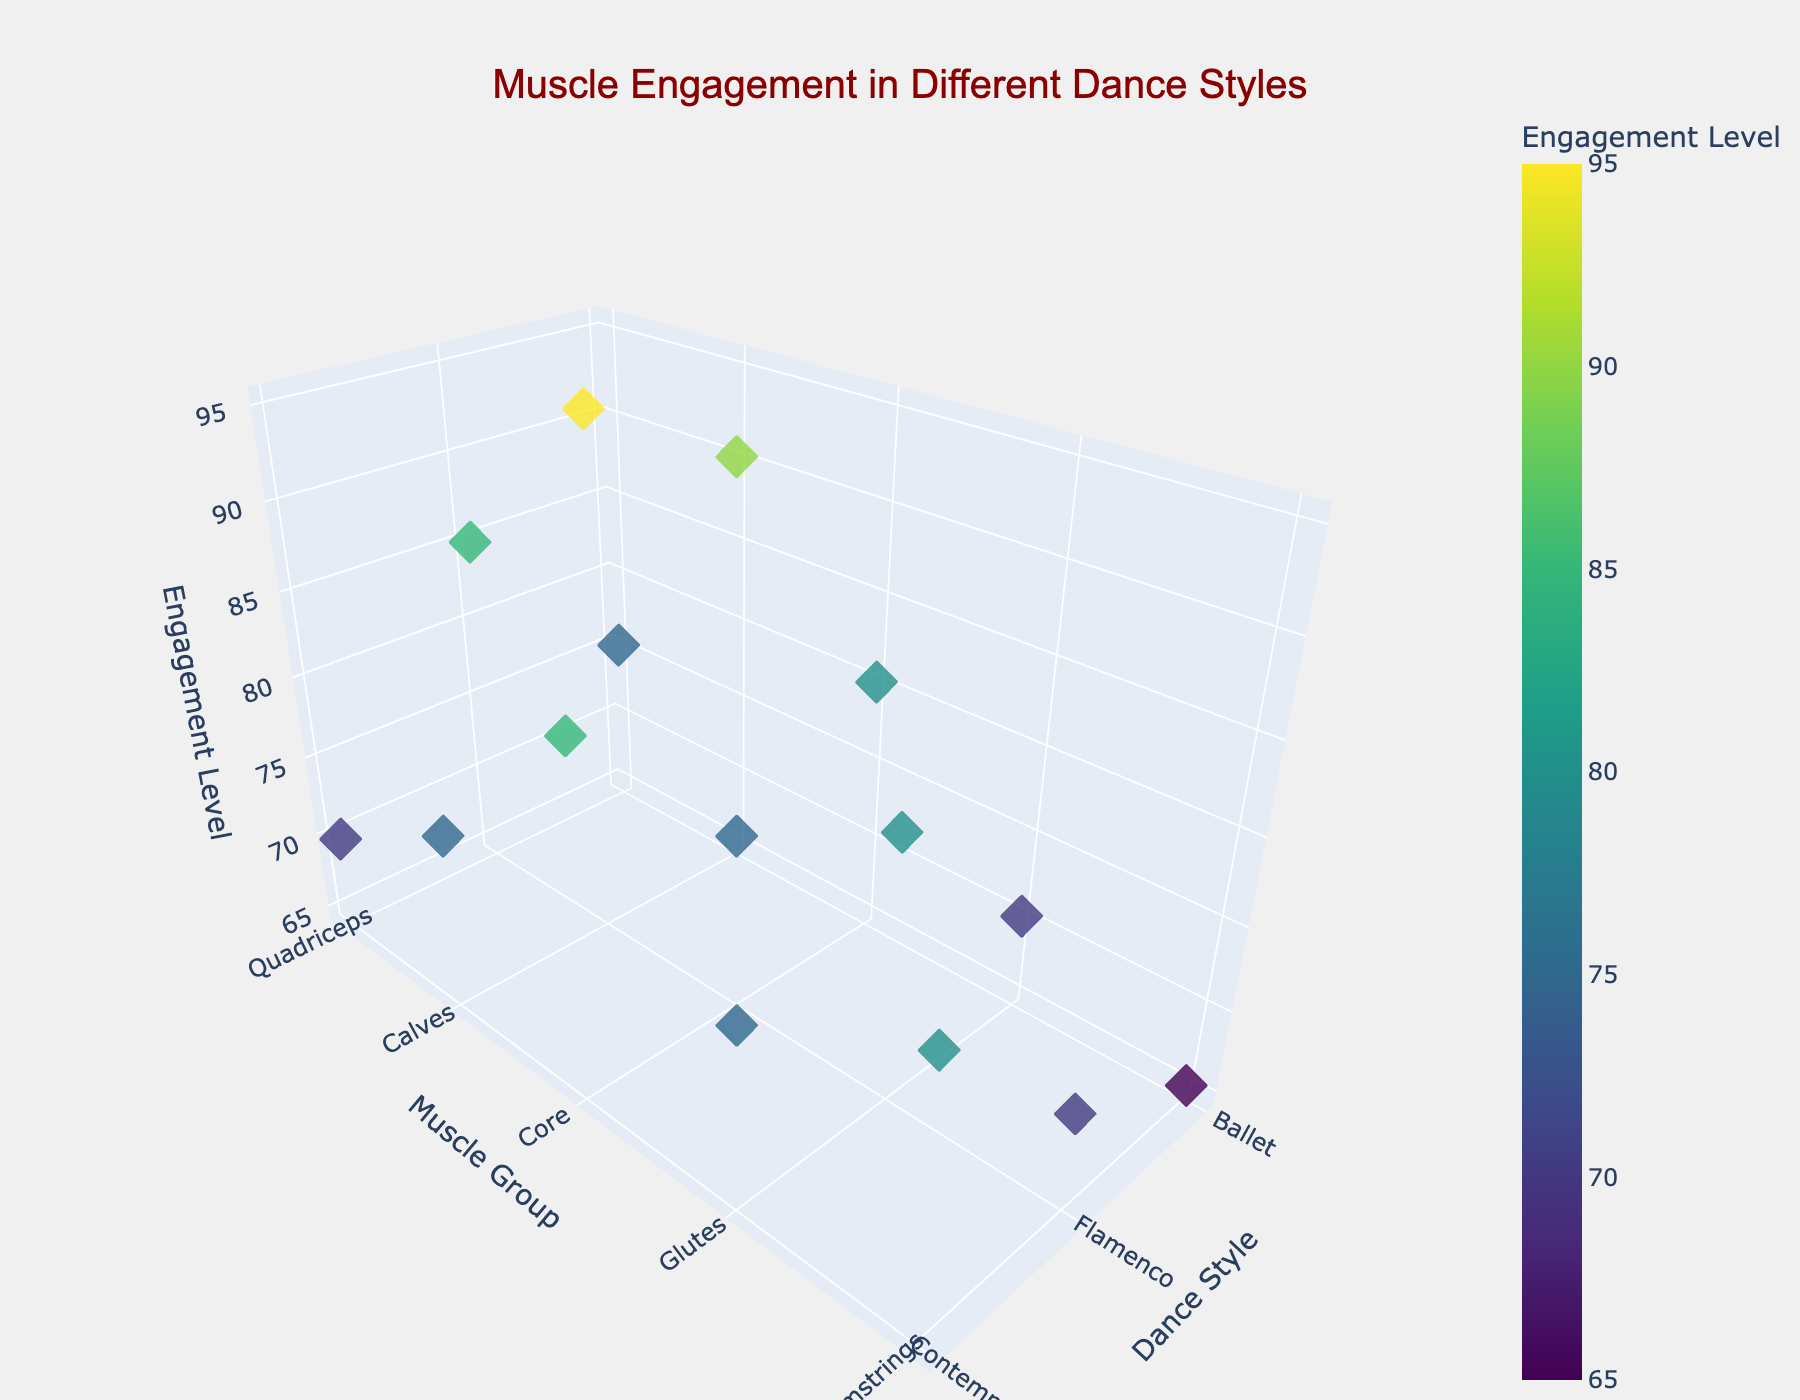What's the title of the plot? The title is typically located at the top of the plot, and it provides a summary of what the plot is about. In this case, the title states "Muscle Engagement in Different Dance Styles."
Answer: Muscle Engagement in Different Dance Styles What does the color scale represent? The color scale, often found as a color bar on the side of the plot, indicates that colors represent different levels of muscle engagement. Darker colors indicate higher engagement levels.
Answer: Engagement Level Which muscle group has the highest engagement level in flamenco? By looking at the y-axis for 'Flamenco' and finding the highest point on the z-axis, you can identify that 'Calves' have the highest engagement level of 95.
Answer: Calves Compare the core muscle engagement between ballet and contemporary dance. Which one is higher? By locating both 'Ballet' and 'Contemporary' groups on the y-axis for the 'Core' muscle, we see that Ballet has an engagement level of 80, and Contemporary has an engagement level of 85. Therefore, Contemporary has a higher core muscle engagement.
Answer: Contemporary What's the average engagement level for the glutes across all dance styles? First, identify the engagement levels for the glutes in ballet, flamenco, and contemporary, which are 70, 80, and 75, respectively. Sum these values (70+80+75 = 225) and divide by the number of dance styles (3) to get the average.
Answer: 75 How many muscle engagement data points are there in the plot? Count the number of markers in the scatter plot, which corresponds to each unique combination of dance style and muscle group. There are 15 such points, as each dance style has 5 muscle group data.
Answer: 15 Which dance style shows the lowest engagement level for hamstrings? By locating the hamstrings on the y-axis and comparing the z-axis values for each dance style, you see that ballet has the lowest engagement level (65).
Answer: Ballet What's the range of engagement levels for the quadriceps across all dance styles? Determine the minimum and maximum engagement levels for the quadriceps from ballet (75), flamenco (85), and contemporary (70). The range is the difference between the maximum and minimum values (85-70 = 15).
Answer: 15 What is the total engagement level for calves across all dance styles? Sum the engagement levels for calves in ballet, flamenco, and contemporary (90, 95, and 75, respectively). The total is 90+95+75 = 260.
Answer: 260 Which muscle group shows the most varied engagement levels across the three dance styles? Look at the engagement levels for each muscle group across ballet, flamenco, and contemporary. The calves, with engagement levels of 90, 95, and 75, have the most variation, with a range of 20 (95-75).
Answer: Calves 